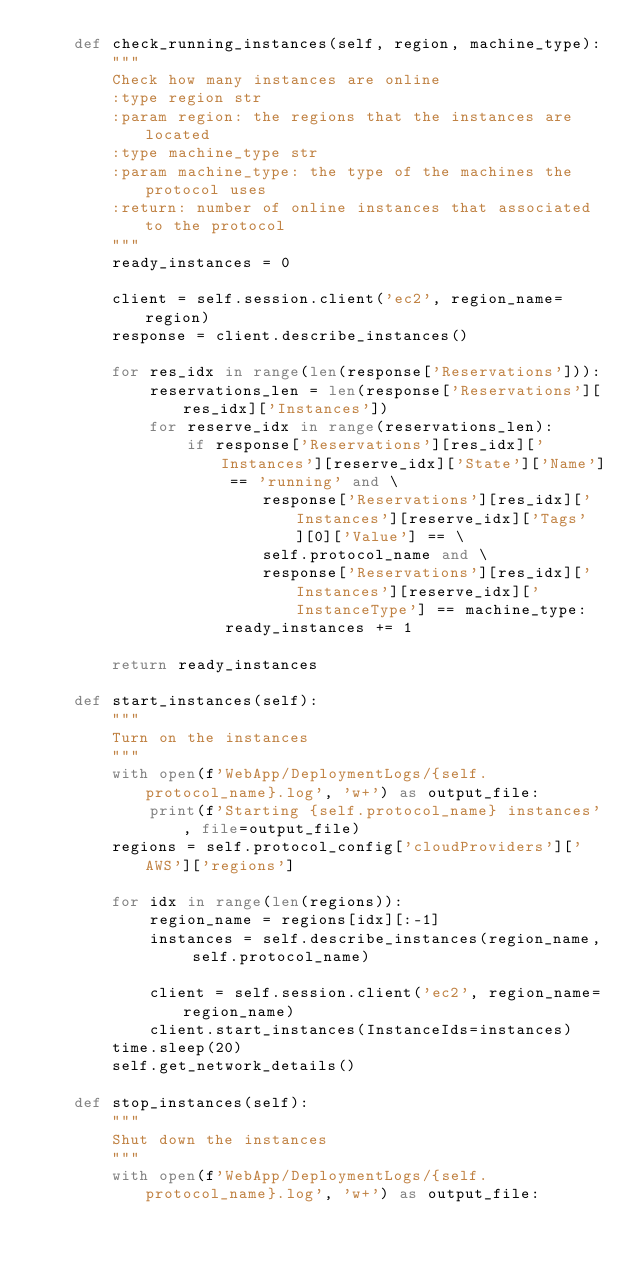Convert code to text. <code><loc_0><loc_0><loc_500><loc_500><_Python_>    def check_running_instances(self, region, machine_type):
        """
        Check how many instances are online
        :type region str
        :param region: the regions that the instances are located
        :type machine_type str
        :param machine_type: the type of the machines the protocol uses
        :return: number of online instances that associated to the protocol
        """
        ready_instances = 0

        client = self.session.client('ec2', region_name=region)
        response = client.describe_instances()

        for res_idx in range(len(response['Reservations'])):
            reservations_len = len(response['Reservations'][res_idx]['Instances'])
            for reserve_idx in range(reservations_len):
                if response['Reservations'][res_idx]['Instances'][reserve_idx]['State']['Name'] == 'running' and \
                        response['Reservations'][res_idx]['Instances'][reserve_idx]['Tags'][0]['Value'] == \
                        self.protocol_name and \
                        response['Reservations'][res_idx]['Instances'][reserve_idx]['InstanceType'] == machine_type:
                    ready_instances += 1

        return ready_instances

    def start_instances(self):
        """
        Turn on the instances
        """
        with open(f'WebApp/DeploymentLogs/{self.protocol_name}.log', 'w+') as output_file:
            print(f'Starting {self.protocol_name} instances', file=output_file)
        regions = self.protocol_config['cloudProviders']['AWS']['regions']

        for idx in range(len(regions)):
            region_name = regions[idx][:-1]
            instances = self.describe_instances(region_name, self.protocol_name)

            client = self.session.client('ec2', region_name=region_name)
            client.start_instances(InstanceIds=instances)
        time.sleep(20)
        self.get_network_details()

    def stop_instances(self):
        """
        Shut down the instances
        """
        with open(f'WebApp/DeploymentLogs/{self.protocol_name}.log', 'w+') as output_file:</code> 